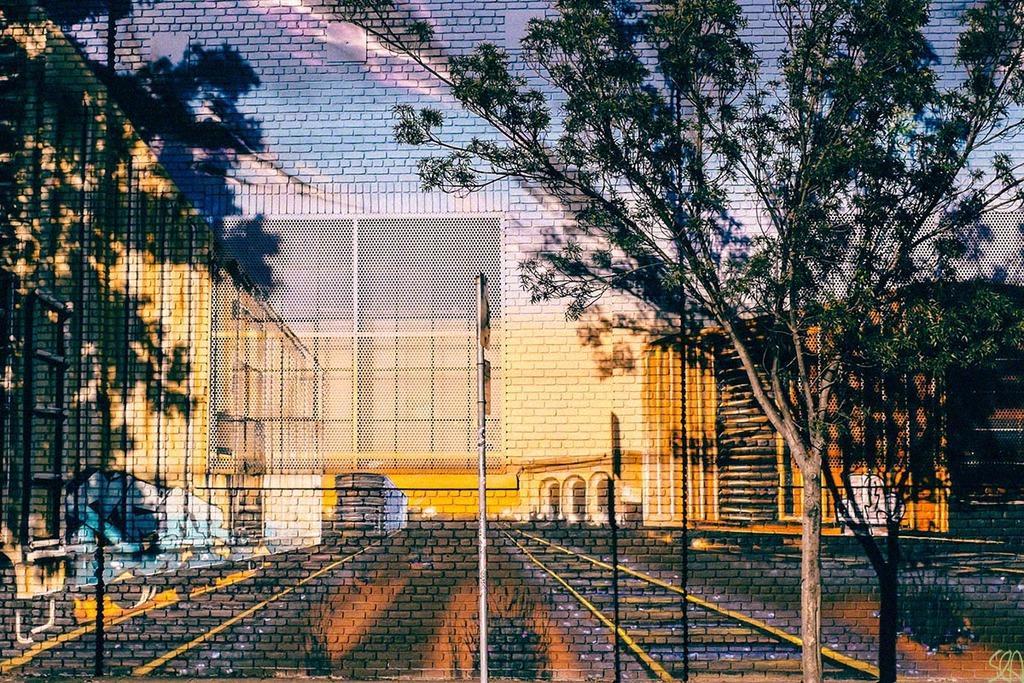Describe this image in one or two sentences. This looks like a 3D wall painting. These are the rail track, fence, buildings and trees. This looks like a pole with the boards attached to it. 